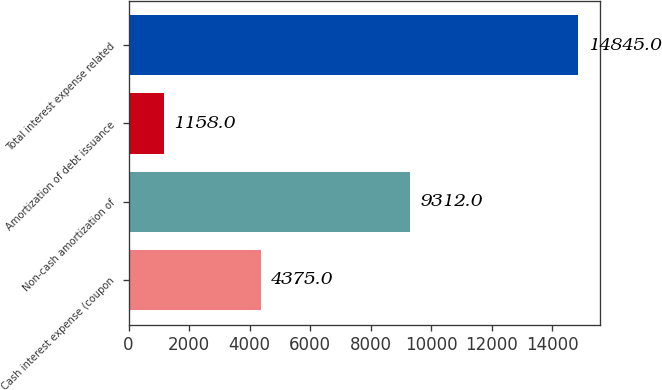Convert chart. <chart><loc_0><loc_0><loc_500><loc_500><bar_chart><fcel>Cash interest expense (coupon<fcel>Non-cash amortization of<fcel>Amortization of debt issuance<fcel>Total interest expense related<nl><fcel>4375<fcel>9312<fcel>1158<fcel>14845<nl></chart> 